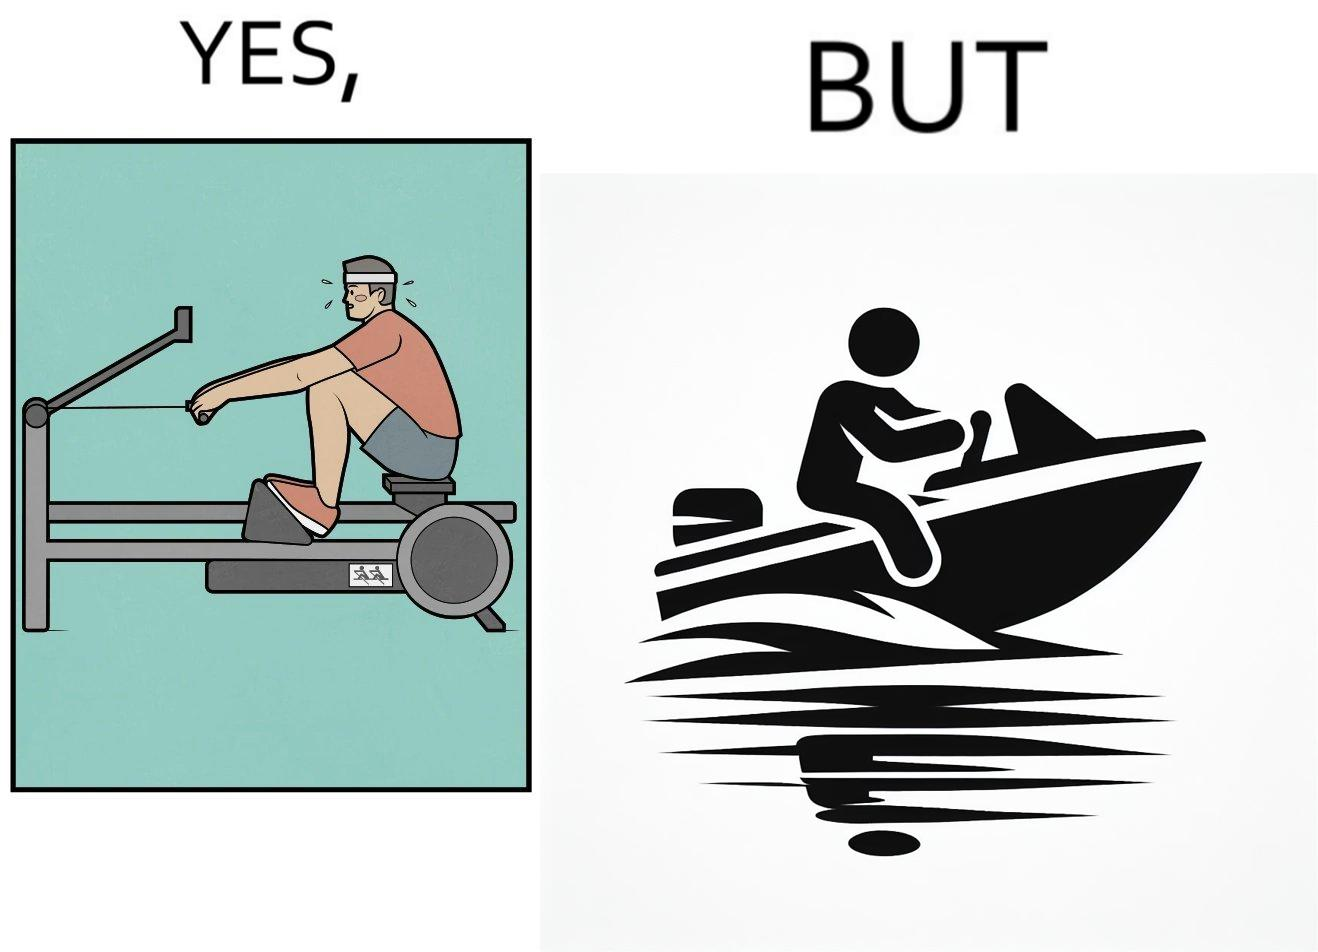Why is this image considered satirical? The image is ironic, because people often use rowing machine at the gym don't prefer rowing when it comes to boats 